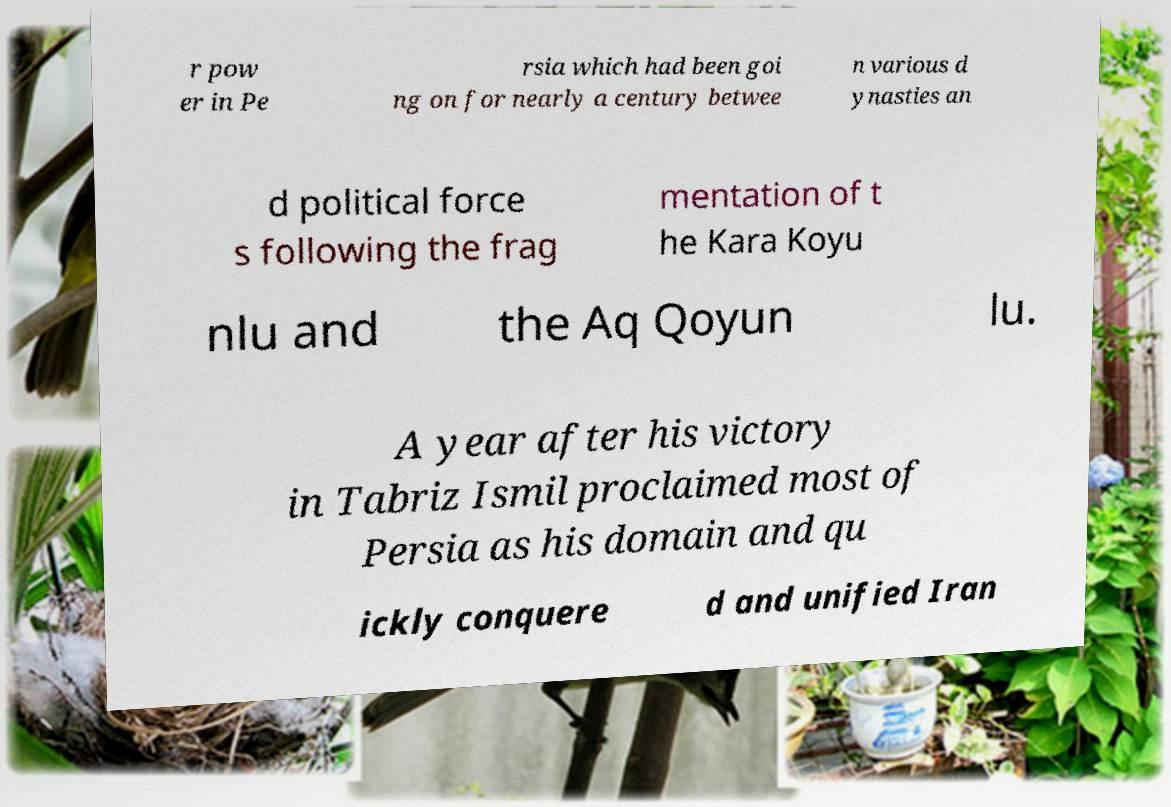Please read and relay the text visible in this image. What does it say? r pow er in Pe rsia which had been goi ng on for nearly a century betwee n various d ynasties an d political force s following the frag mentation of t he Kara Koyu nlu and the Aq Qoyun lu. A year after his victory in Tabriz Ismil proclaimed most of Persia as his domain and qu ickly conquere d and unified Iran 